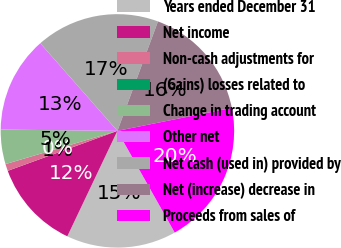Convert chart. <chart><loc_0><loc_0><loc_500><loc_500><pie_chart><fcel>Years ended December 31<fcel>Net income<fcel>Non-cash adjustments for<fcel>(Gains) losses related to<fcel>Change in trading account<fcel>Other net<fcel>Net cash (used in) provided by<fcel>Net (increase) decrease in<fcel>Proceeds from sales of<nl><fcel>15.23%<fcel>12.38%<fcel>0.96%<fcel>0.01%<fcel>4.77%<fcel>13.33%<fcel>17.14%<fcel>16.19%<fcel>19.99%<nl></chart> 